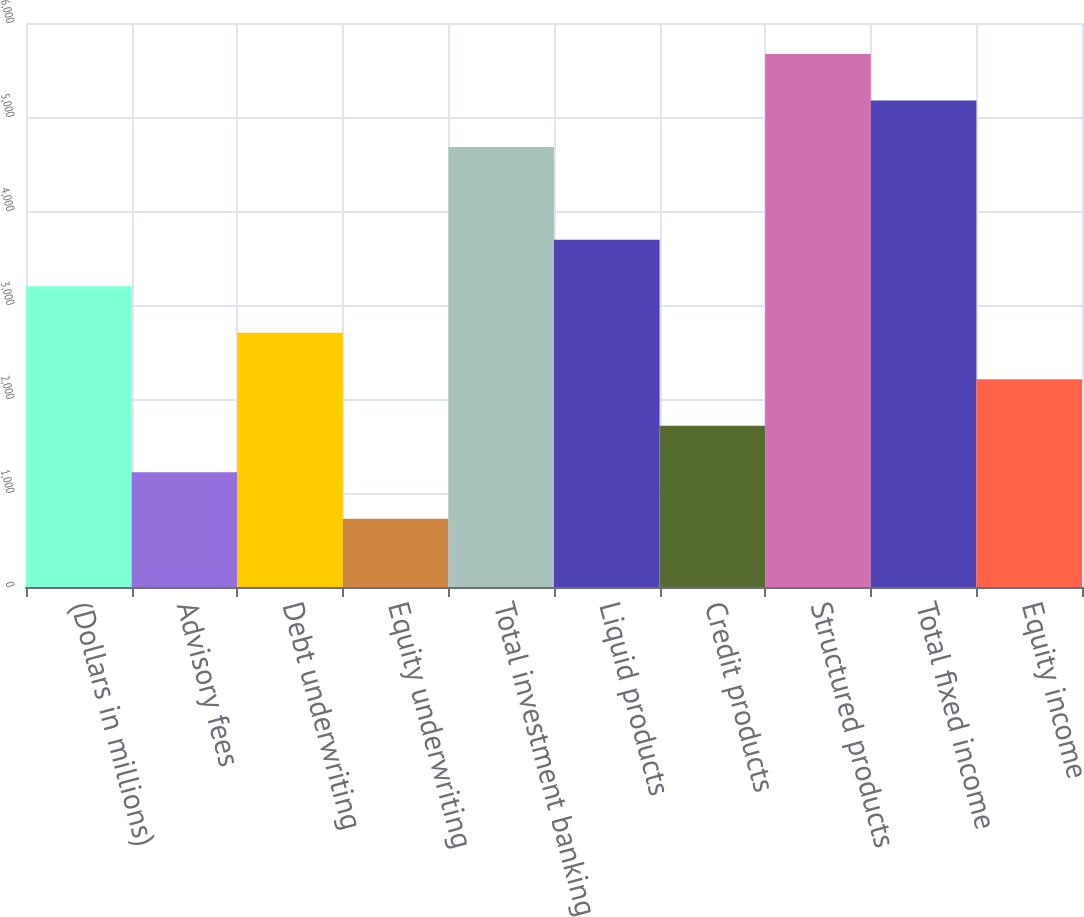Convert chart. <chart><loc_0><loc_0><loc_500><loc_500><bar_chart><fcel>(Dollars in millions)<fcel>Advisory fees<fcel>Debt underwriting<fcel>Equity underwriting<fcel>Total investment banking<fcel>Liquid products<fcel>Credit products<fcel>Structured products<fcel>Total fixed income<fcel>Equity income<nl><fcel>3198.8<fcel>1221.6<fcel>2704.5<fcel>727.3<fcel>4681.7<fcel>3693.1<fcel>1715.9<fcel>5670.3<fcel>5176<fcel>2210.2<nl></chart> 